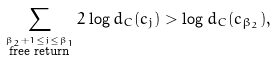<formula> <loc_0><loc_0><loc_500><loc_500>\sum _ { \stackrel { \beta _ { 2 } + 1 \leq j \leq \beta _ { 1 } } { \text {free return} } } 2 \log d _ { C } ( c _ { j } ) > \log d _ { C } ( c _ { \beta _ { 2 } } ) ,</formula> 